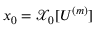<formula> <loc_0><loc_0><loc_500><loc_500>x _ { 0 } = \mathcal { X } _ { 0 } [ U ^ { ( m ) } ]</formula> 